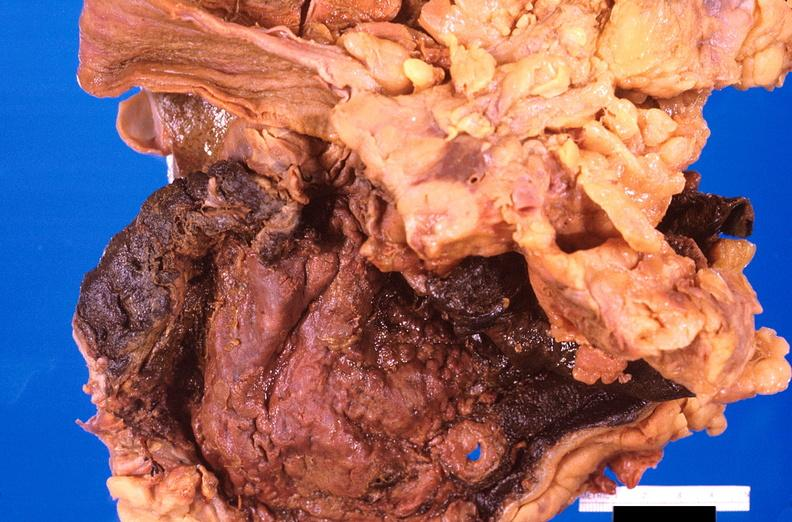what does this image show?
Answer the question using a single word or phrase. Stomach 